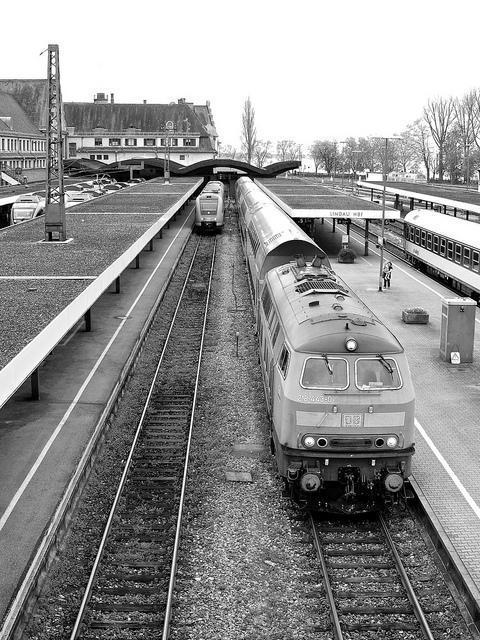How many trains are visible?
Give a very brief answer. 2. 